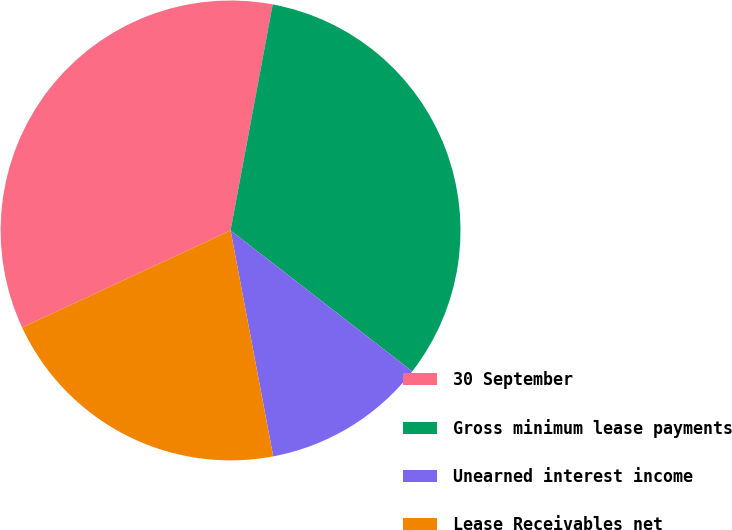Convert chart to OTSL. <chart><loc_0><loc_0><loc_500><loc_500><pie_chart><fcel>30 September<fcel>Gross minimum lease payments<fcel>Unearned interest income<fcel>Lease Receivables net<nl><fcel>34.87%<fcel>32.56%<fcel>11.53%<fcel>21.03%<nl></chart> 